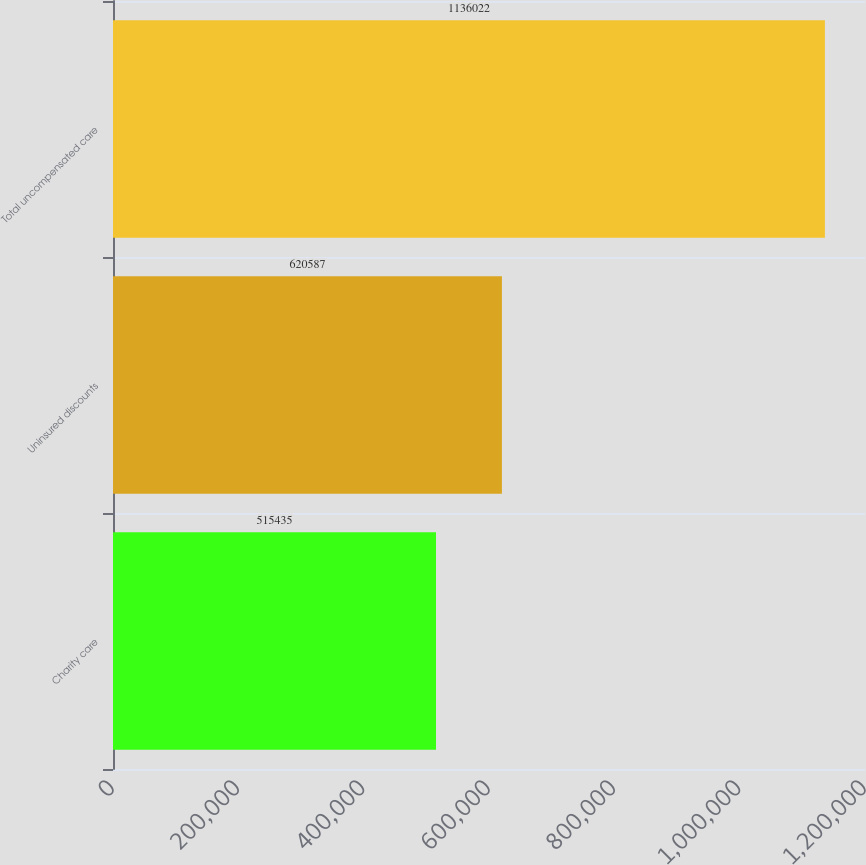<chart> <loc_0><loc_0><loc_500><loc_500><bar_chart><fcel>Charity care<fcel>Uninsured discounts<fcel>Total uncompensated care<nl><fcel>515435<fcel>620587<fcel>1.13602e+06<nl></chart> 